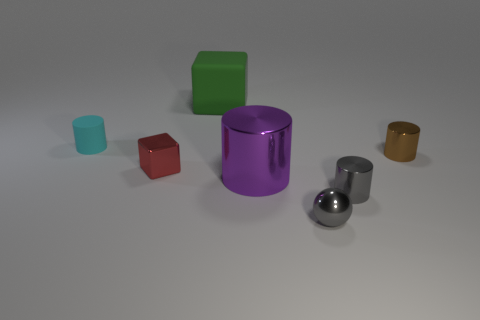Add 2 gray metal cylinders. How many objects exist? 9 Subtract all blocks. How many objects are left? 5 Subtract 0 yellow blocks. How many objects are left? 7 Subtract all metal things. Subtract all tiny brown cylinders. How many objects are left? 1 Add 5 gray things. How many gray things are left? 7 Add 5 big shiny balls. How many big shiny balls exist? 5 